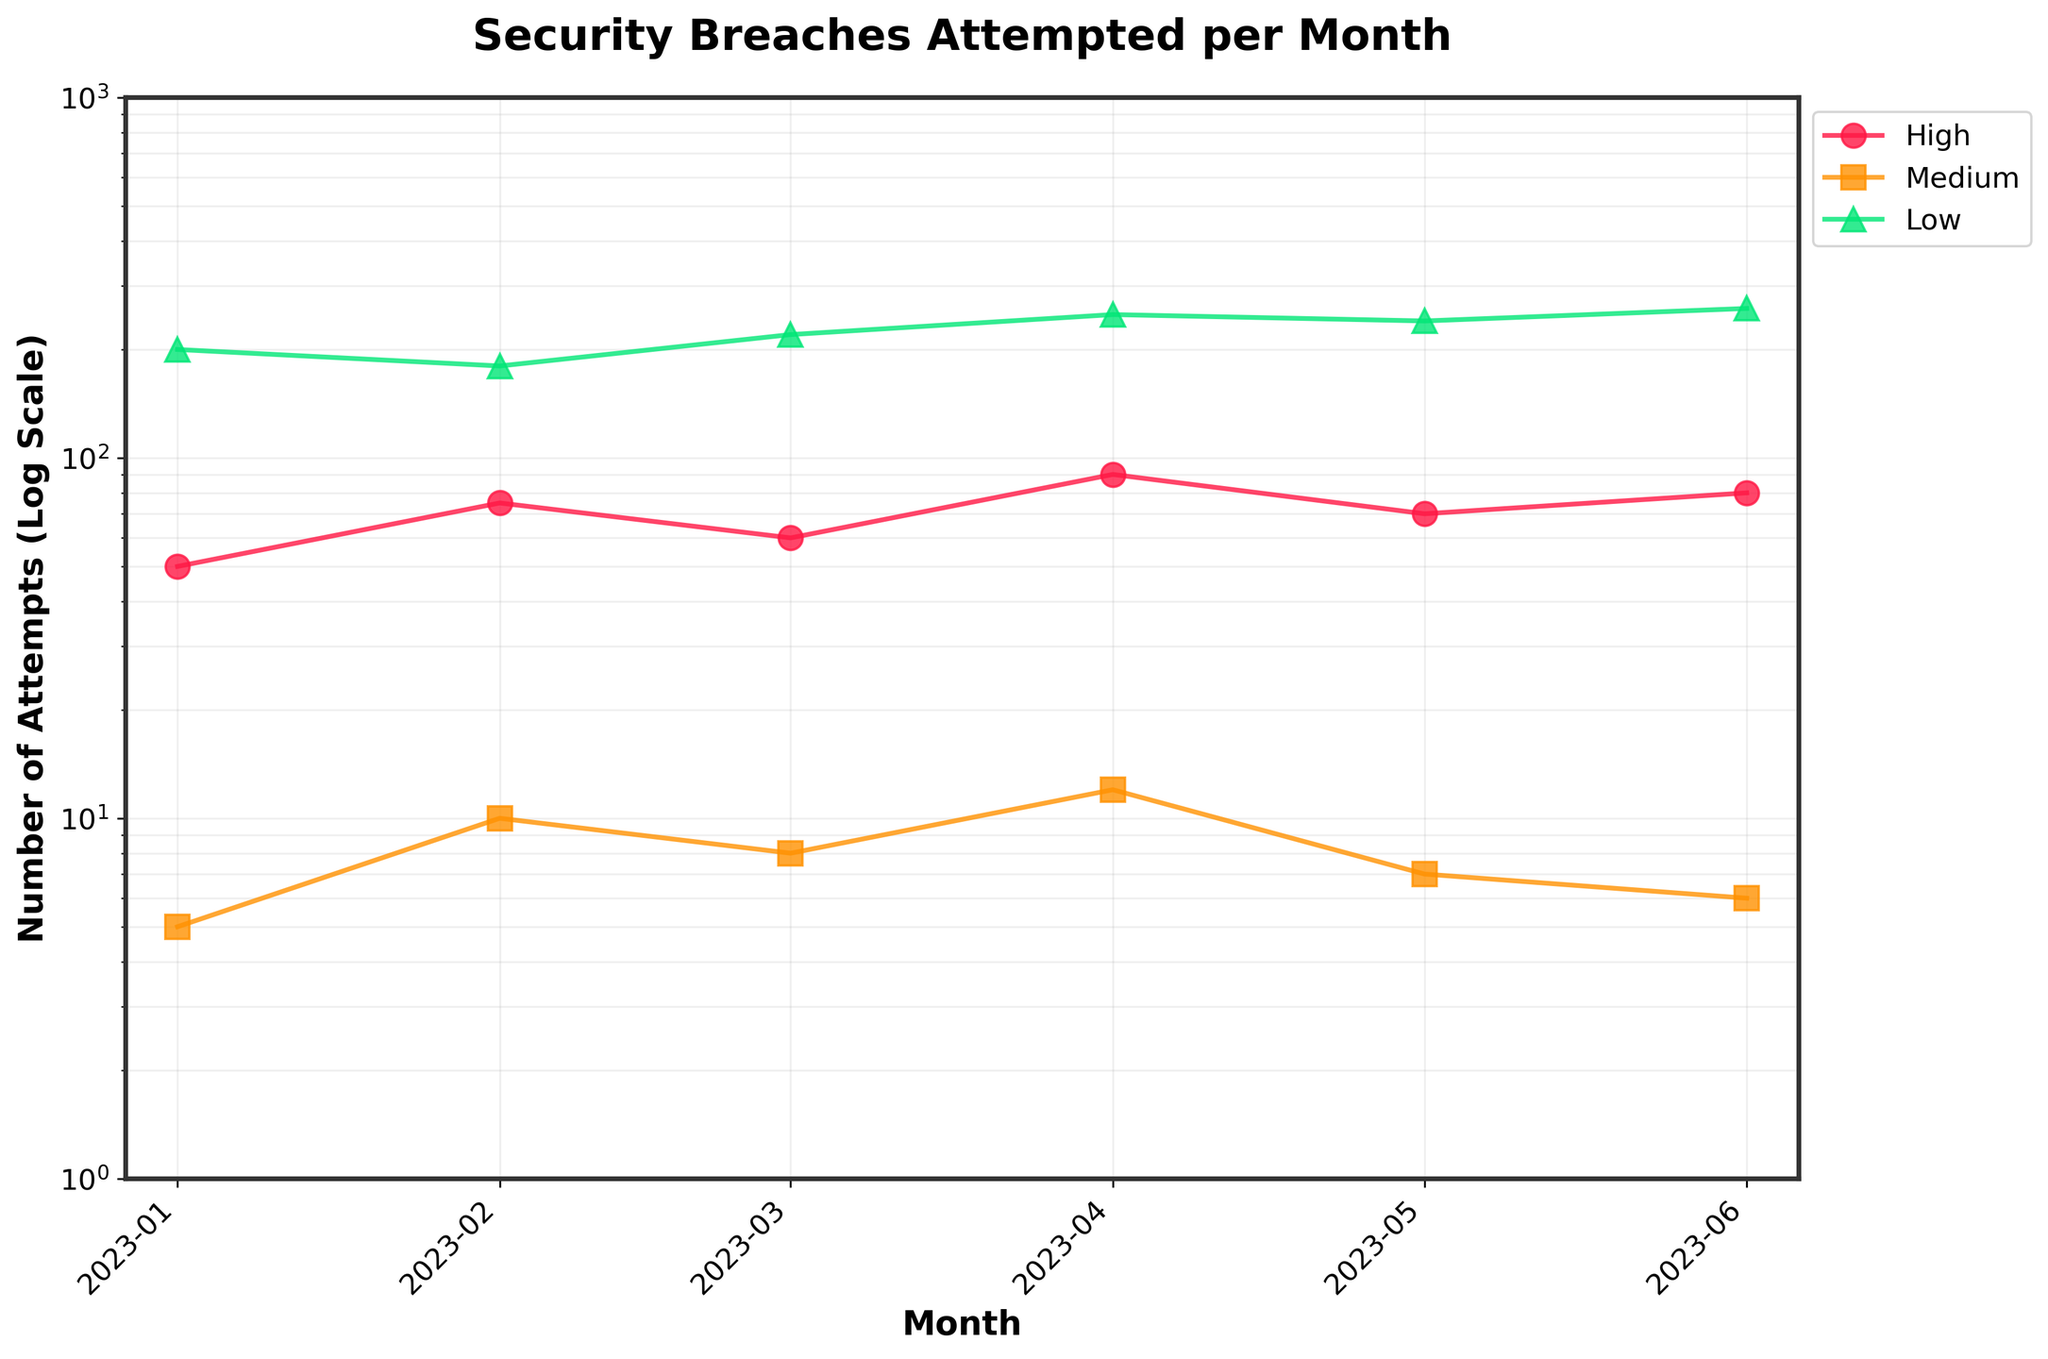How many unique severity levels are represented in the figure? The figure shows three different series labeled 'High', 'Medium', and 'Low'.
Answer: 3 Which month had the highest number of high severity attempts? From the plot, the peak for high severity attempts can be identified in April 2023.
Answer: April 2023 What is the log-scaled y-axis range? The y-axis range is from 1 to 1000 on the log scale.
Answer: 1 to 1000 How many data points are there for each severity level? Each month has one data point for each severity level, with data spanning six months. Thus, each severity level has 6 data points.
Answer: 6 Which month had the fewest medium severity attempts, and how many were there? By observing the chart, May 2023 had the fewest medium severity attempts, which were 7.
Answer: May 2023, 7 What is the average number of low severity attempts across all months? Sum the number of low severity attempts for each month (200 + 180 + 220 + 250 + 240 + 260) and divide by 6. The calculation yields an average of 225.
Answer: 225 In which month did the medium severity attempts show an increase compared to the previous month? Compare the values from month to month; March 2023 had a higher number of medium severity attempts (8) compared to February 2023 (6).
Answer: March 2023 Which severity level shows the highest variability in the number of attempts? By observing the spread of the values on the log scale, low severity attempts range from 180 to 260, showing the highest variability.
Answer: Low How does the trend of high severity attempts compare from January 2023 to June 2023? High severity attempts generally show an increasing trend from January 2023 (50) to June 2023 (80) with some fluctuations.
Answer: Increasing trend Is there a consistent relationship between the number of high and medium severity attempts throughout the data? High severity attempts are consistently higher than medium severity attempts across all months, showing a clear pattern.
Answer: Yes 